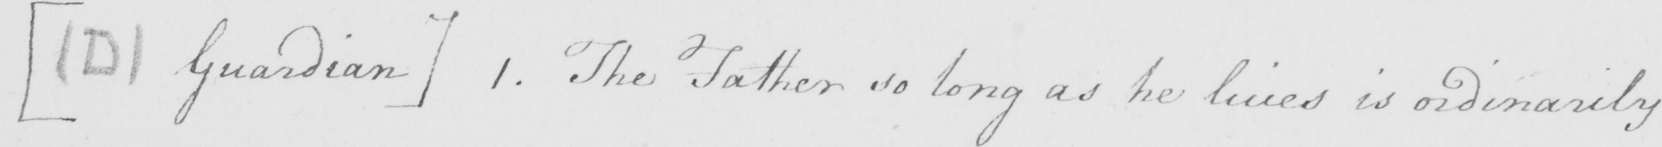What text is written in this handwritten line? [  ( D )  Guardian ]  1 . The Father so long as he lives is ordinarily 